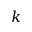Convert formula to latex. <formula><loc_0><loc_0><loc_500><loc_500>k</formula> 